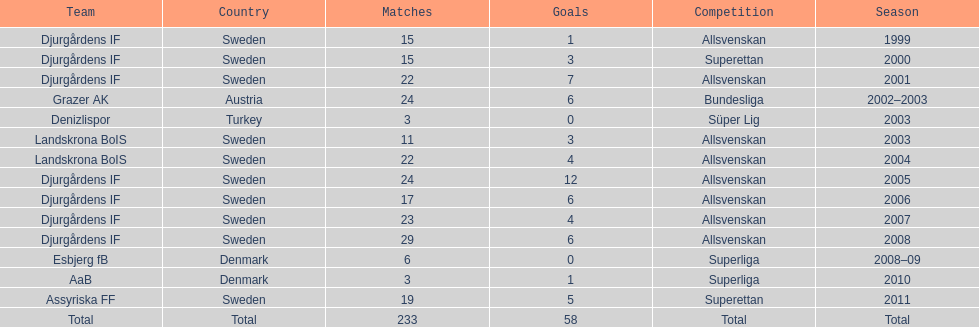What was the number of goals he scored in 2005? 12. 